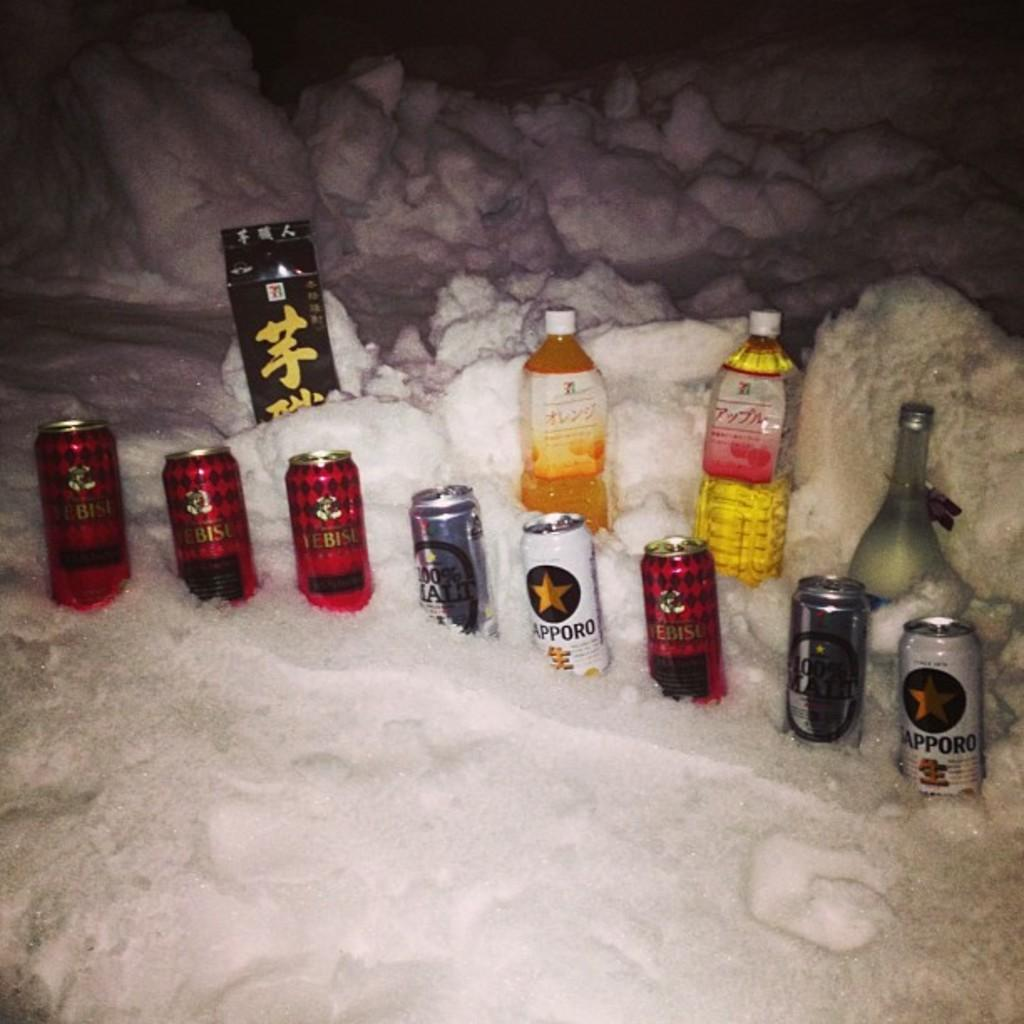What is the primary feature of the landscape in the image? There is snow in the image. What objects are placed on the snow? There are tins, bottles, and a box on the snow. What time of day was the image taken? The image was taken at night time. Can you see your uncle in the image? There is no person, including an uncle, present in the image. What type of flower can be seen growing in the snow? There are no flowers visible in the image; it only features tins, bottles, a box, and snow. 